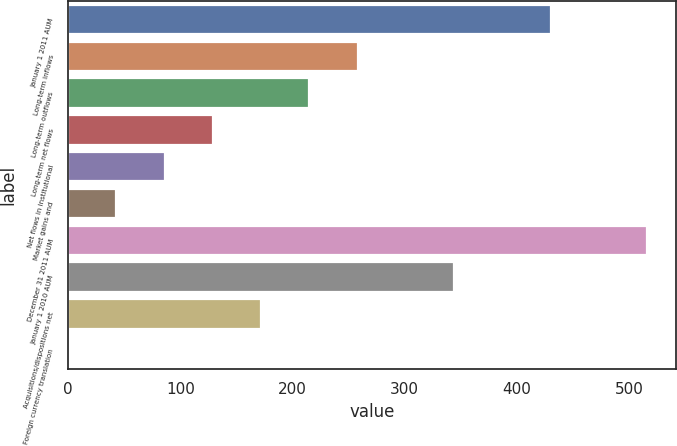<chart> <loc_0><loc_0><loc_500><loc_500><bar_chart><fcel>January 1 2011 AUM<fcel>Long-term inflows<fcel>Long-term outflows<fcel>Long-term net flows<fcel>Net flows in institutional<fcel>Market gains and<fcel>December 31 2011 AUM<fcel>January 1 2010 AUM<fcel>Acquisitions/dispositions net<fcel>Foreign currency translation<nl><fcel>430<fcel>258.04<fcel>215.05<fcel>129.07<fcel>86.08<fcel>43.09<fcel>515.98<fcel>344.02<fcel>172.06<fcel>0.1<nl></chart> 